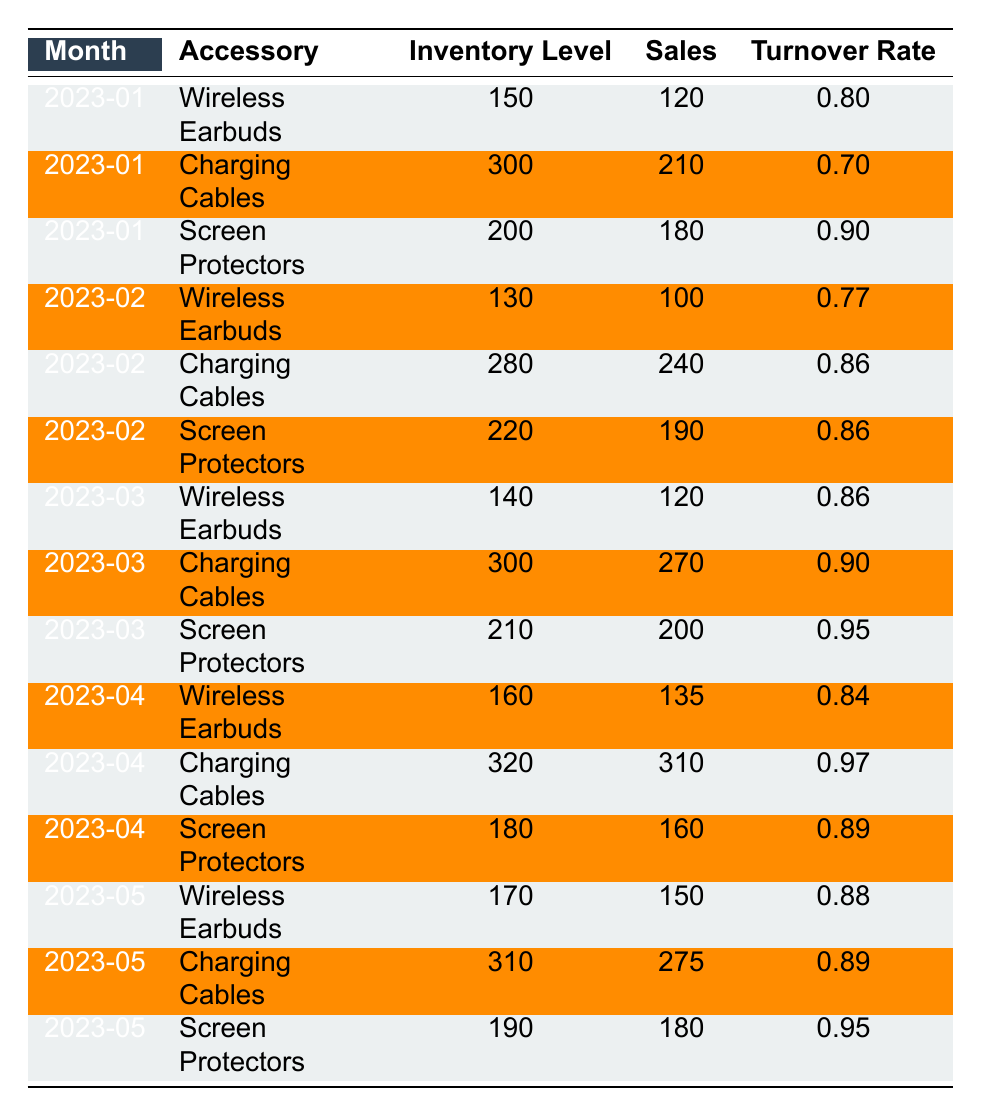What is the turnover rate for Charging Cables in March 2023? The table shows that the turnover rate for Charging Cables in March 2023 is listed directly as 0.90.
Answer: 0.90 How many Wireless Earbuds were sold in April 2023? In the table, the sales figure for Wireless Earbuds in April 2023 is recorded as 135.
Answer: 135 What is the average sales figure for Screen Protectors over the five months? To calculate the average, sum the sales figures for Screen Protectors: (180 + 190 + 200 + 160 + 180) = 1110. Then divide by the number of months, which is 5: 1110/5 = 222.
Answer: 222 Did Charging Cables have the highest turnover rate in April 2023 compared to other months? A comparison shows that Charging Cables in April 2023 had a turnover rate of 0.97, which is higher than the rates for the other two accessories in the same month (0.84 for Wireless Earbuds and 0.89 for Screen Protectors).
Answer: Yes What is the total inventory level for Wireless Earbuds over the five months? To find the total inventory, add the inventory levels for Wireless Earbuds: (150 + 130 + 140 + 160 + 170) = 750.
Answer: 750 Which accessory had the most consistent turnover rate throughout the months? Evaluating the turnover rates for each accessory shows that Screen Protectors varied between 0.90, 0.86, 0.95, 0.89, and 0.95, which indicates less variance compared to the others. Therefore, Screen Protectors had the most consistent turnover rate overall.
Answer: Screen Protectors What was the increase in inventory for Charging Cables from March to April 2023? The inventory for Charging Cables in March 2023 was 300 and in April 2023 was 320. The increase can be calculated as 320 - 300 = 20.
Answer: 20 In which month did Wireless Earbuds see the highest sales? Looking at the sales figures for Wireless Earbuds in each month reveals that the highest sales occurred in May 2023 with 150 units sold.
Answer: May 2023 How much did sales of Charging Cables increase from February to March 2023? The sales of Charging Cables increased from 240 in February to 270 in March. The difference is 270 - 240 = 30.
Answer: 30 Was the total sales figure for March 2023 higher than the total for February 2023? The total sales for March 2023 can be summed up as 120 (Wireless Earbuds) + 270 (Charging Cables) + 200 (Screen Protectors) = 590. For February 2023, the total is 100 (Wireless Earbuds) + 240 (Charging Cables) + 190 (Screen Protectors) = 530. Since 590 > 530, the total for March was higher.
Answer: Yes What is the monthly average turnover rate for Charging Cables across all months? To determine the average turnover rate for Charging Cables: (0.70 + 0.86 + 0.90 + 0.97 + 0.89) = 4.32. Then, divide by the number of months, 5: 4.32/5 = 0.864.
Answer: 0.864 